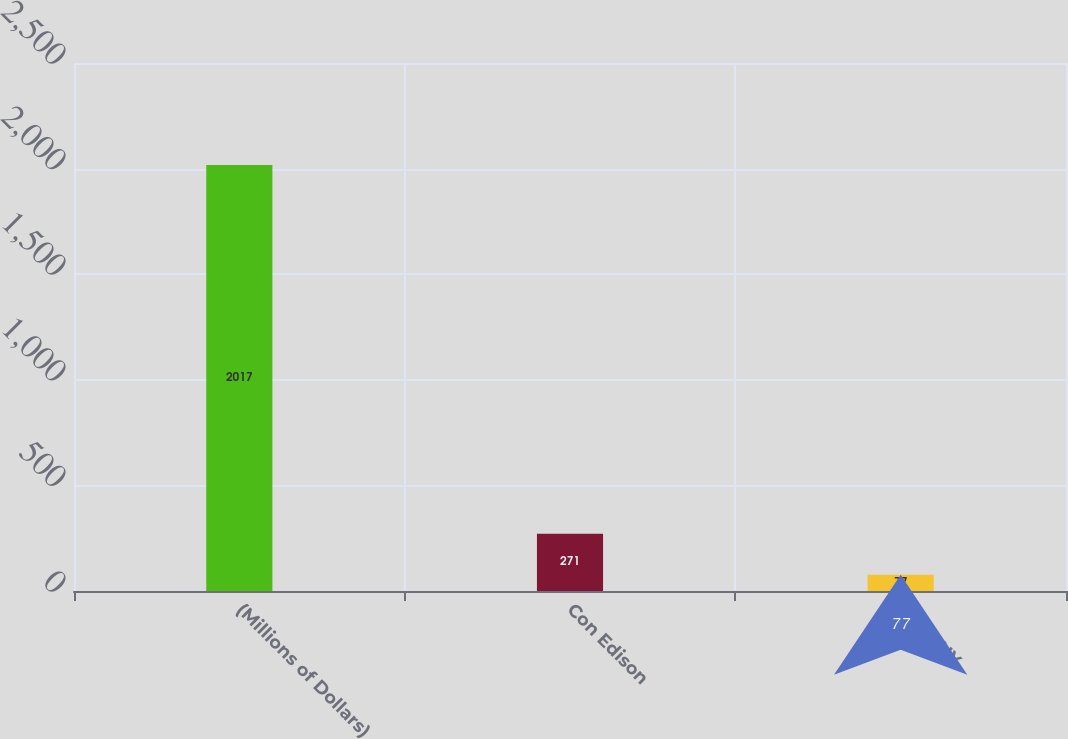Convert chart. <chart><loc_0><loc_0><loc_500><loc_500><bar_chart><fcel>(Millions of Dollars)<fcel>Con Edison<fcel>CECONY<nl><fcel>2017<fcel>271<fcel>77<nl></chart> 